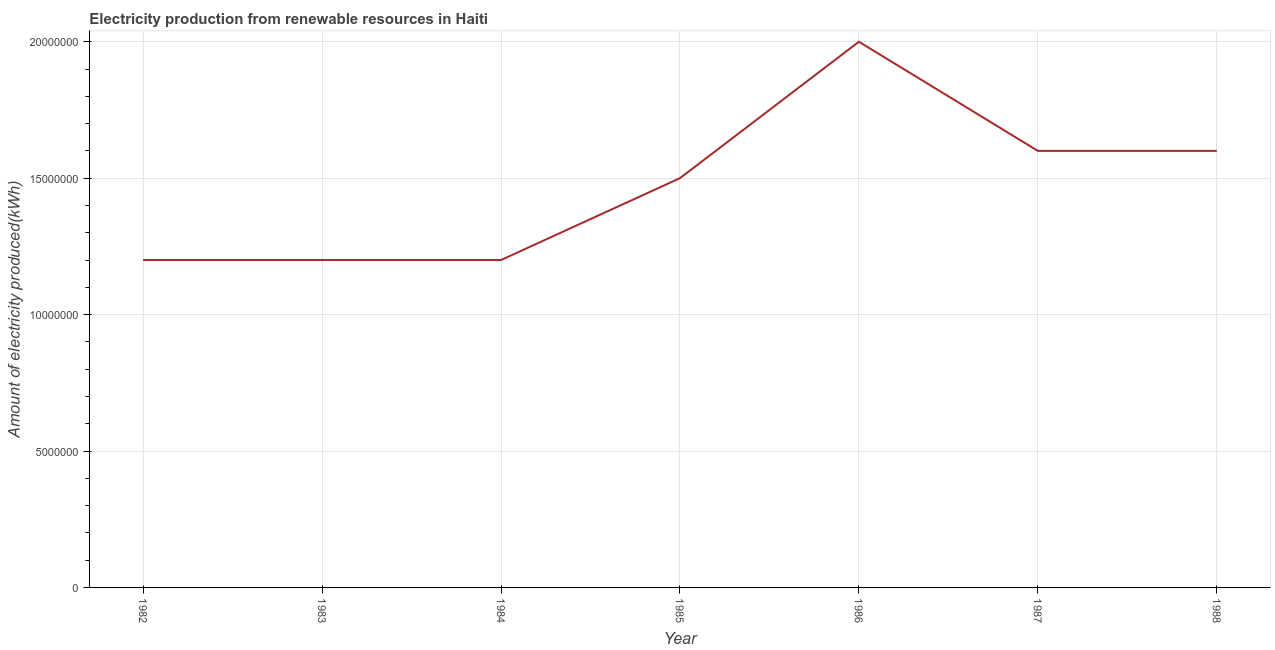What is the amount of electricity produced in 1988?
Ensure brevity in your answer.  1.60e+07. Across all years, what is the maximum amount of electricity produced?
Your response must be concise. 2.00e+07. Across all years, what is the minimum amount of electricity produced?
Keep it short and to the point. 1.20e+07. In which year was the amount of electricity produced maximum?
Give a very brief answer. 1986. What is the sum of the amount of electricity produced?
Provide a succinct answer. 1.03e+08. What is the difference between the amount of electricity produced in 1984 and 1986?
Give a very brief answer. -8.00e+06. What is the average amount of electricity produced per year?
Your response must be concise. 1.47e+07. What is the median amount of electricity produced?
Provide a succinct answer. 1.50e+07. In how many years, is the amount of electricity produced greater than 16000000 kWh?
Ensure brevity in your answer.  1. Do a majority of the years between 1982 and 1988 (inclusive) have amount of electricity produced greater than 15000000 kWh?
Offer a terse response. No. What is the difference between the highest and the lowest amount of electricity produced?
Your answer should be very brief. 8.00e+06. In how many years, is the amount of electricity produced greater than the average amount of electricity produced taken over all years?
Keep it short and to the point. 4. How many years are there in the graph?
Your answer should be very brief. 7. Are the values on the major ticks of Y-axis written in scientific E-notation?
Your response must be concise. No. Does the graph contain any zero values?
Provide a succinct answer. No. Does the graph contain grids?
Provide a succinct answer. Yes. What is the title of the graph?
Offer a terse response. Electricity production from renewable resources in Haiti. What is the label or title of the X-axis?
Offer a very short reply. Year. What is the label or title of the Y-axis?
Keep it short and to the point. Amount of electricity produced(kWh). What is the Amount of electricity produced(kWh) in 1985?
Give a very brief answer. 1.50e+07. What is the Amount of electricity produced(kWh) of 1986?
Ensure brevity in your answer.  2.00e+07. What is the Amount of electricity produced(kWh) in 1987?
Provide a succinct answer. 1.60e+07. What is the Amount of electricity produced(kWh) in 1988?
Ensure brevity in your answer.  1.60e+07. What is the difference between the Amount of electricity produced(kWh) in 1982 and 1983?
Provide a succinct answer. 0. What is the difference between the Amount of electricity produced(kWh) in 1982 and 1984?
Your answer should be very brief. 0. What is the difference between the Amount of electricity produced(kWh) in 1982 and 1986?
Offer a terse response. -8.00e+06. What is the difference between the Amount of electricity produced(kWh) in 1982 and 1987?
Offer a very short reply. -4.00e+06. What is the difference between the Amount of electricity produced(kWh) in 1983 and 1984?
Provide a succinct answer. 0. What is the difference between the Amount of electricity produced(kWh) in 1983 and 1985?
Your answer should be very brief. -3.00e+06. What is the difference between the Amount of electricity produced(kWh) in 1983 and 1986?
Provide a succinct answer. -8.00e+06. What is the difference between the Amount of electricity produced(kWh) in 1983 and 1987?
Offer a very short reply. -4.00e+06. What is the difference between the Amount of electricity produced(kWh) in 1984 and 1986?
Provide a succinct answer. -8.00e+06. What is the difference between the Amount of electricity produced(kWh) in 1984 and 1987?
Offer a terse response. -4.00e+06. What is the difference between the Amount of electricity produced(kWh) in 1984 and 1988?
Your answer should be very brief. -4.00e+06. What is the difference between the Amount of electricity produced(kWh) in 1985 and 1986?
Your response must be concise. -5.00e+06. What is the difference between the Amount of electricity produced(kWh) in 1987 and 1988?
Offer a terse response. 0. What is the ratio of the Amount of electricity produced(kWh) in 1982 to that in 1983?
Give a very brief answer. 1. What is the ratio of the Amount of electricity produced(kWh) in 1982 to that in 1986?
Provide a succinct answer. 0.6. What is the ratio of the Amount of electricity produced(kWh) in 1983 to that in 1986?
Make the answer very short. 0.6. What is the ratio of the Amount of electricity produced(kWh) in 1983 to that in 1987?
Make the answer very short. 0.75. What is the ratio of the Amount of electricity produced(kWh) in 1984 to that in 1987?
Provide a succinct answer. 0.75. What is the ratio of the Amount of electricity produced(kWh) in 1985 to that in 1986?
Your answer should be very brief. 0.75. What is the ratio of the Amount of electricity produced(kWh) in 1985 to that in 1987?
Offer a terse response. 0.94. What is the ratio of the Amount of electricity produced(kWh) in 1985 to that in 1988?
Your answer should be compact. 0.94. What is the ratio of the Amount of electricity produced(kWh) in 1986 to that in 1988?
Your answer should be very brief. 1.25. What is the ratio of the Amount of electricity produced(kWh) in 1987 to that in 1988?
Provide a short and direct response. 1. 